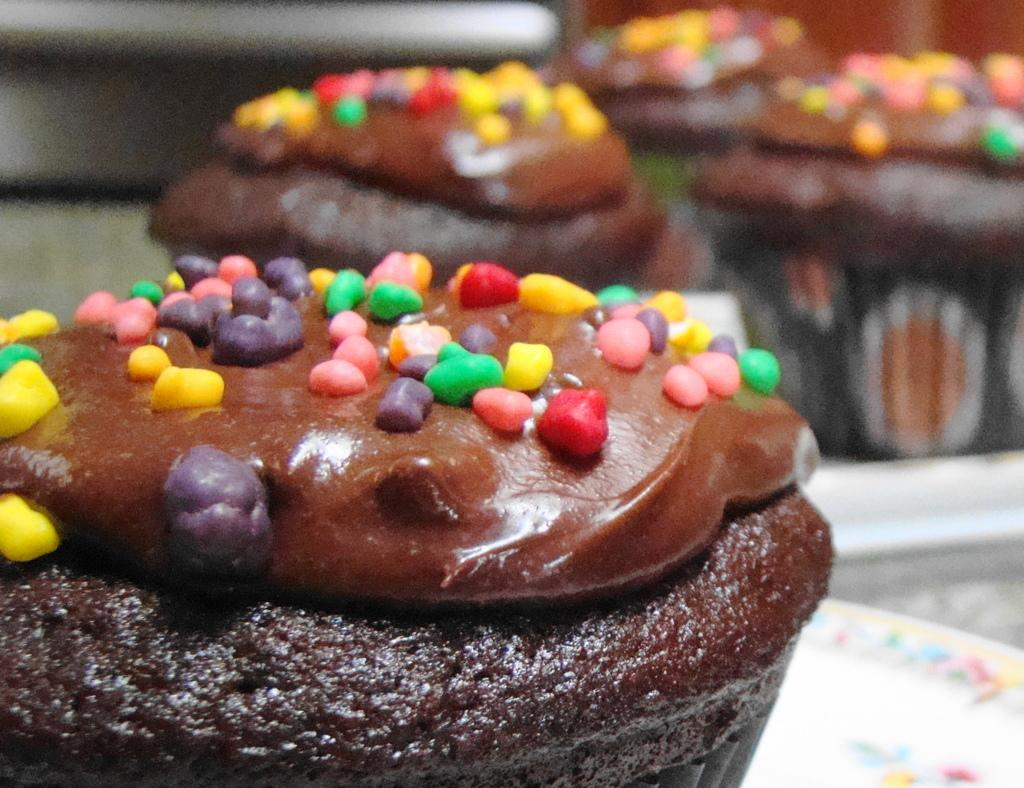What is placed on the table in the image? There are cupcakes placed on a table. What type of town can be seen in the background of the image? There is no town visible in the image; it only shows cupcakes placed on a table. Where is the nest located in the image? There is no nest present in the image. 